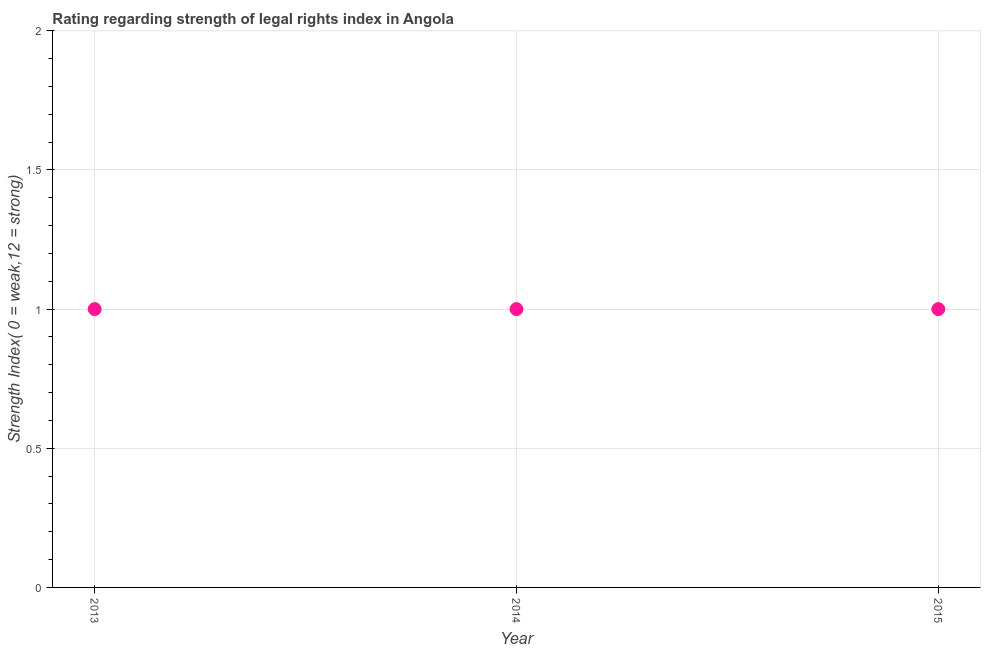What is the strength of legal rights index in 2015?
Your answer should be very brief. 1. Across all years, what is the maximum strength of legal rights index?
Your response must be concise. 1. Across all years, what is the minimum strength of legal rights index?
Your answer should be very brief. 1. In which year was the strength of legal rights index maximum?
Give a very brief answer. 2013. What is the sum of the strength of legal rights index?
Your answer should be very brief. 3. What is the difference between the strength of legal rights index in 2014 and 2015?
Offer a very short reply. 0. What is the ratio of the strength of legal rights index in 2014 to that in 2015?
Offer a very short reply. 1. Is the difference between the strength of legal rights index in 2013 and 2014 greater than the difference between any two years?
Your response must be concise. Yes. What is the difference between the highest and the second highest strength of legal rights index?
Give a very brief answer. 0. Is the sum of the strength of legal rights index in 2014 and 2015 greater than the maximum strength of legal rights index across all years?
Ensure brevity in your answer.  Yes. What is the difference between the highest and the lowest strength of legal rights index?
Give a very brief answer. 0. Does the strength of legal rights index monotonically increase over the years?
Provide a short and direct response. No. How many dotlines are there?
Make the answer very short. 1. Does the graph contain any zero values?
Make the answer very short. No. What is the title of the graph?
Keep it short and to the point. Rating regarding strength of legal rights index in Angola. What is the label or title of the X-axis?
Offer a terse response. Year. What is the label or title of the Y-axis?
Make the answer very short. Strength Index( 0 = weak,12 = strong). What is the Strength Index( 0 = weak,12 = strong) in 2014?
Provide a succinct answer. 1. What is the Strength Index( 0 = weak,12 = strong) in 2015?
Make the answer very short. 1. What is the difference between the Strength Index( 0 = weak,12 = strong) in 2013 and 2014?
Make the answer very short. 0. What is the difference between the Strength Index( 0 = weak,12 = strong) in 2013 and 2015?
Your answer should be very brief. 0. What is the ratio of the Strength Index( 0 = weak,12 = strong) in 2013 to that in 2014?
Offer a terse response. 1. What is the ratio of the Strength Index( 0 = weak,12 = strong) in 2013 to that in 2015?
Offer a terse response. 1. 